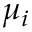<formula> <loc_0><loc_0><loc_500><loc_500>\mu _ { i }</formula> 